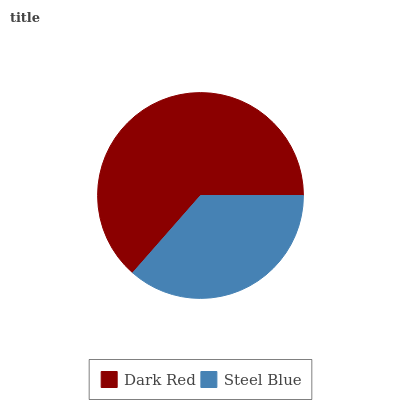Is Steel Blue the minimum?
Answer yes or no. Yes. Is Dark Red the maximum?
Answer yes or no. Yes. Is Steel Blue the maximum?
Answer yes or no. No. Is Dark Red greater than Steel Blue?
Answer yes or no. Yes. Is Steel Blue less than Dark Red?
Answer yes or no. Yes. Is Steel Blue greater than Dark Red?
Answer yes or no. No. Is Dark Red less than Steel Blue?
Answer yes or no. No. Is Dark Red the high median?
Answer yes or no. Yes. Is Steel Blue the low median?
Answer yes or no. Yes. Is Steel Blue the high median?
Answer yes or no. No. Is Dark Red the low median?
Answer yes or no. No. 